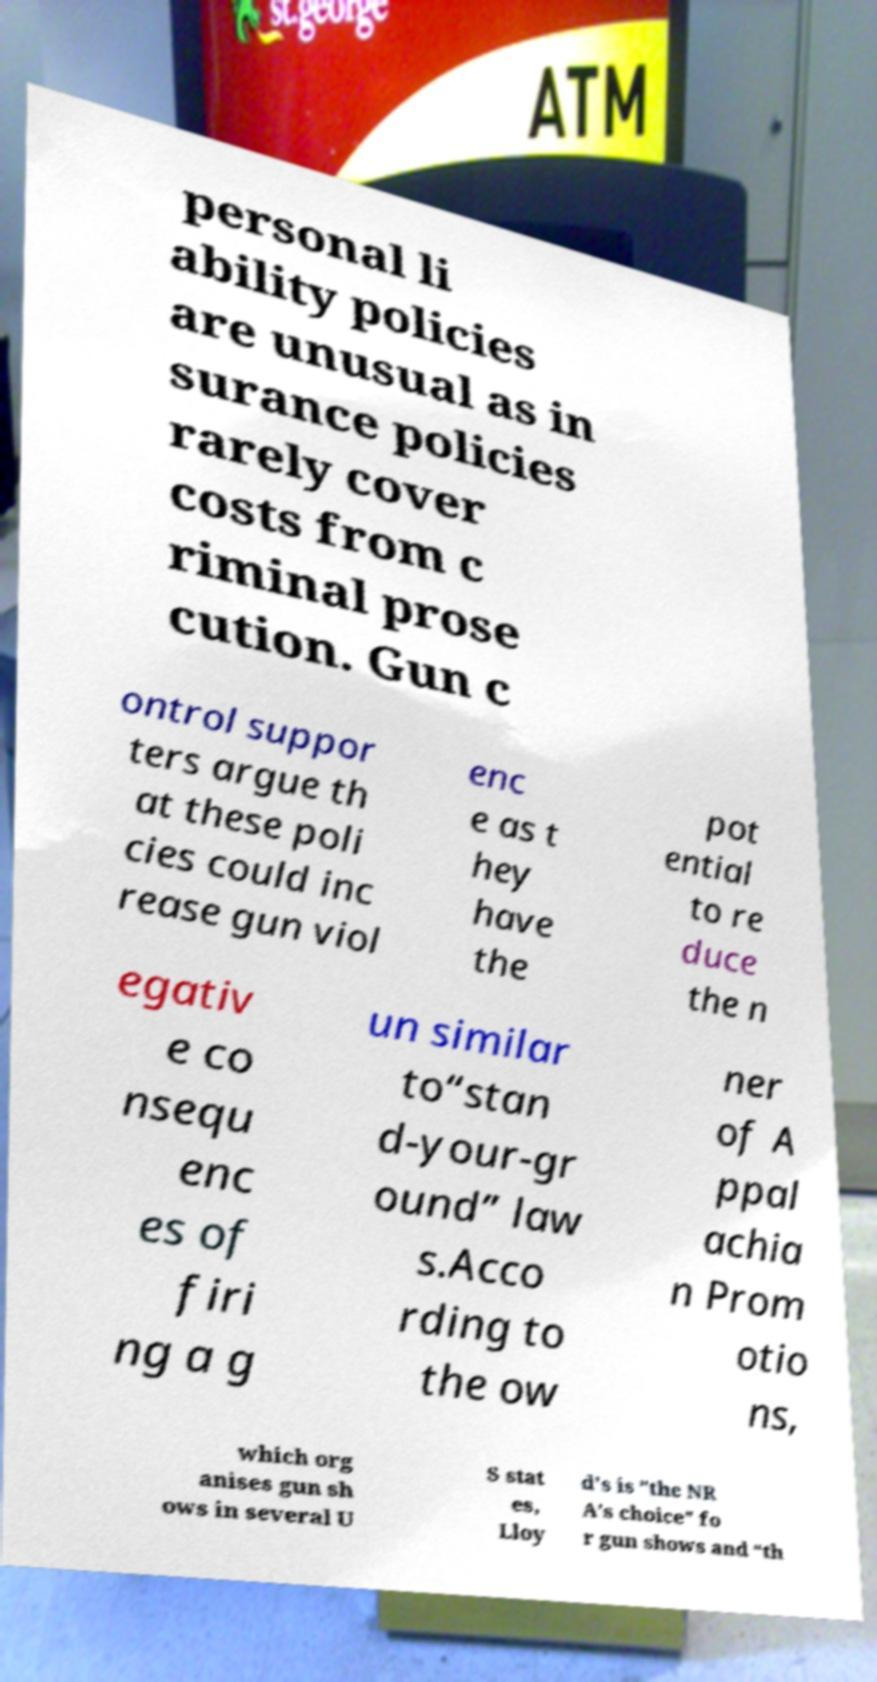For documentation purposes, I need the text within this image transcribed. Could you provide that? personal li ability policies are unusual as in surance policies rarely cover costs from c riminal prose cution. Gun c ontrol suppor ters argue th at these poli cies could inc rease gun viol enc e as t hey have the pot ential to re duce the n egativ e co nsequ enc es of firi ng a g un similar to“stan d-your-gr ound” law s.Acco rding to the ow ner of A ppal achia n Prom otio ns, which org anises gun sh ows in several U S stat es, Lloy d's is "the NR A’s choice” fo r gun shows and “th 